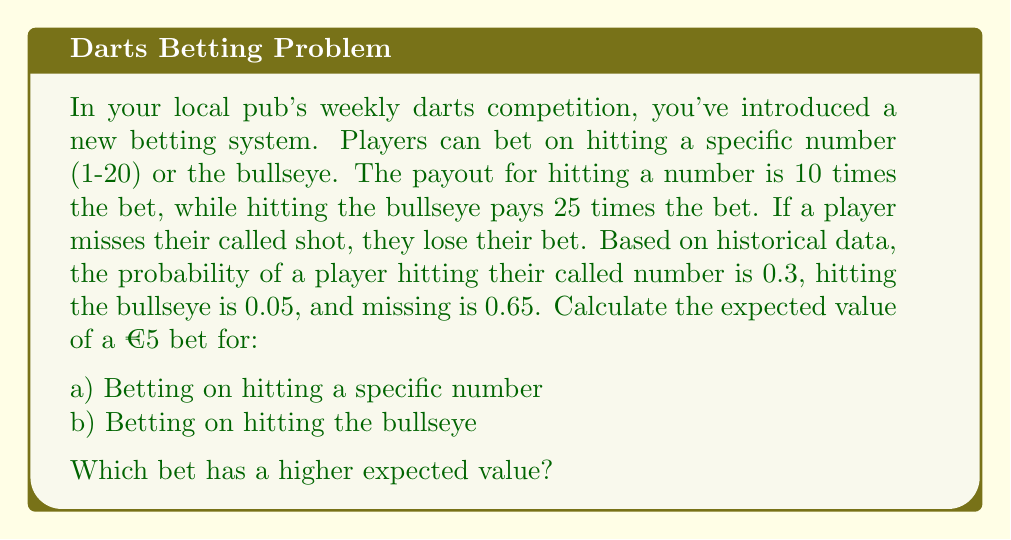Give your solution to this math problem. To solve this problem, we need to calculate the expected value for each betting scenario. The expected value is the sum of each possible outcome multiplied by its probability.

a) Betting on hitting a specific number:

Let's define the possible outcomes and their probabilities:
- Hit the number: Probability = 0.3, Payout = €50 (10 times the €5 bet)
- Miss: Probability = 0.7 (0.65 + 0.05), Payout = €0 (lose the €5 bet)

Expected Value = (Probability of hitting × Payout if hit) + (Probability of missing × Payout if miss) - Initial bet

$$E(\text{number}) = (0.3 \times €50) + (0.7 \times €0) - €5$$
$$E(\text{number}) = €15 + €0 - €5 = €10$$

b) Betting on hitting the bullseye:

- Hit the bullseye: Probability = 0.05, Payout = €125 (25 times the €5 bet)
- Miss: Probability = 0.95 (0.65 + 0.3), Payout = €0 (lose the €5 bet)

$$E(\text{bullseye}) = (0.05 \times €125) + (0.95 \times €0) - €5$$
$$E(\text{bullseye}) = €6.25 + €0 - €5 = €1.25$$

To determine which bet has a higher expected value, we compare the two results:

$$E(\text{number}) = €10 > E(\text{bullseye}) = €1.25$$
Answer: a) The expected value of betting €5 on hitting a specific number is €10.
b) The expected value of betting €5 on hitting the bullseye is €1.25.
Betting on hitting a specific number has a higher expected value. 